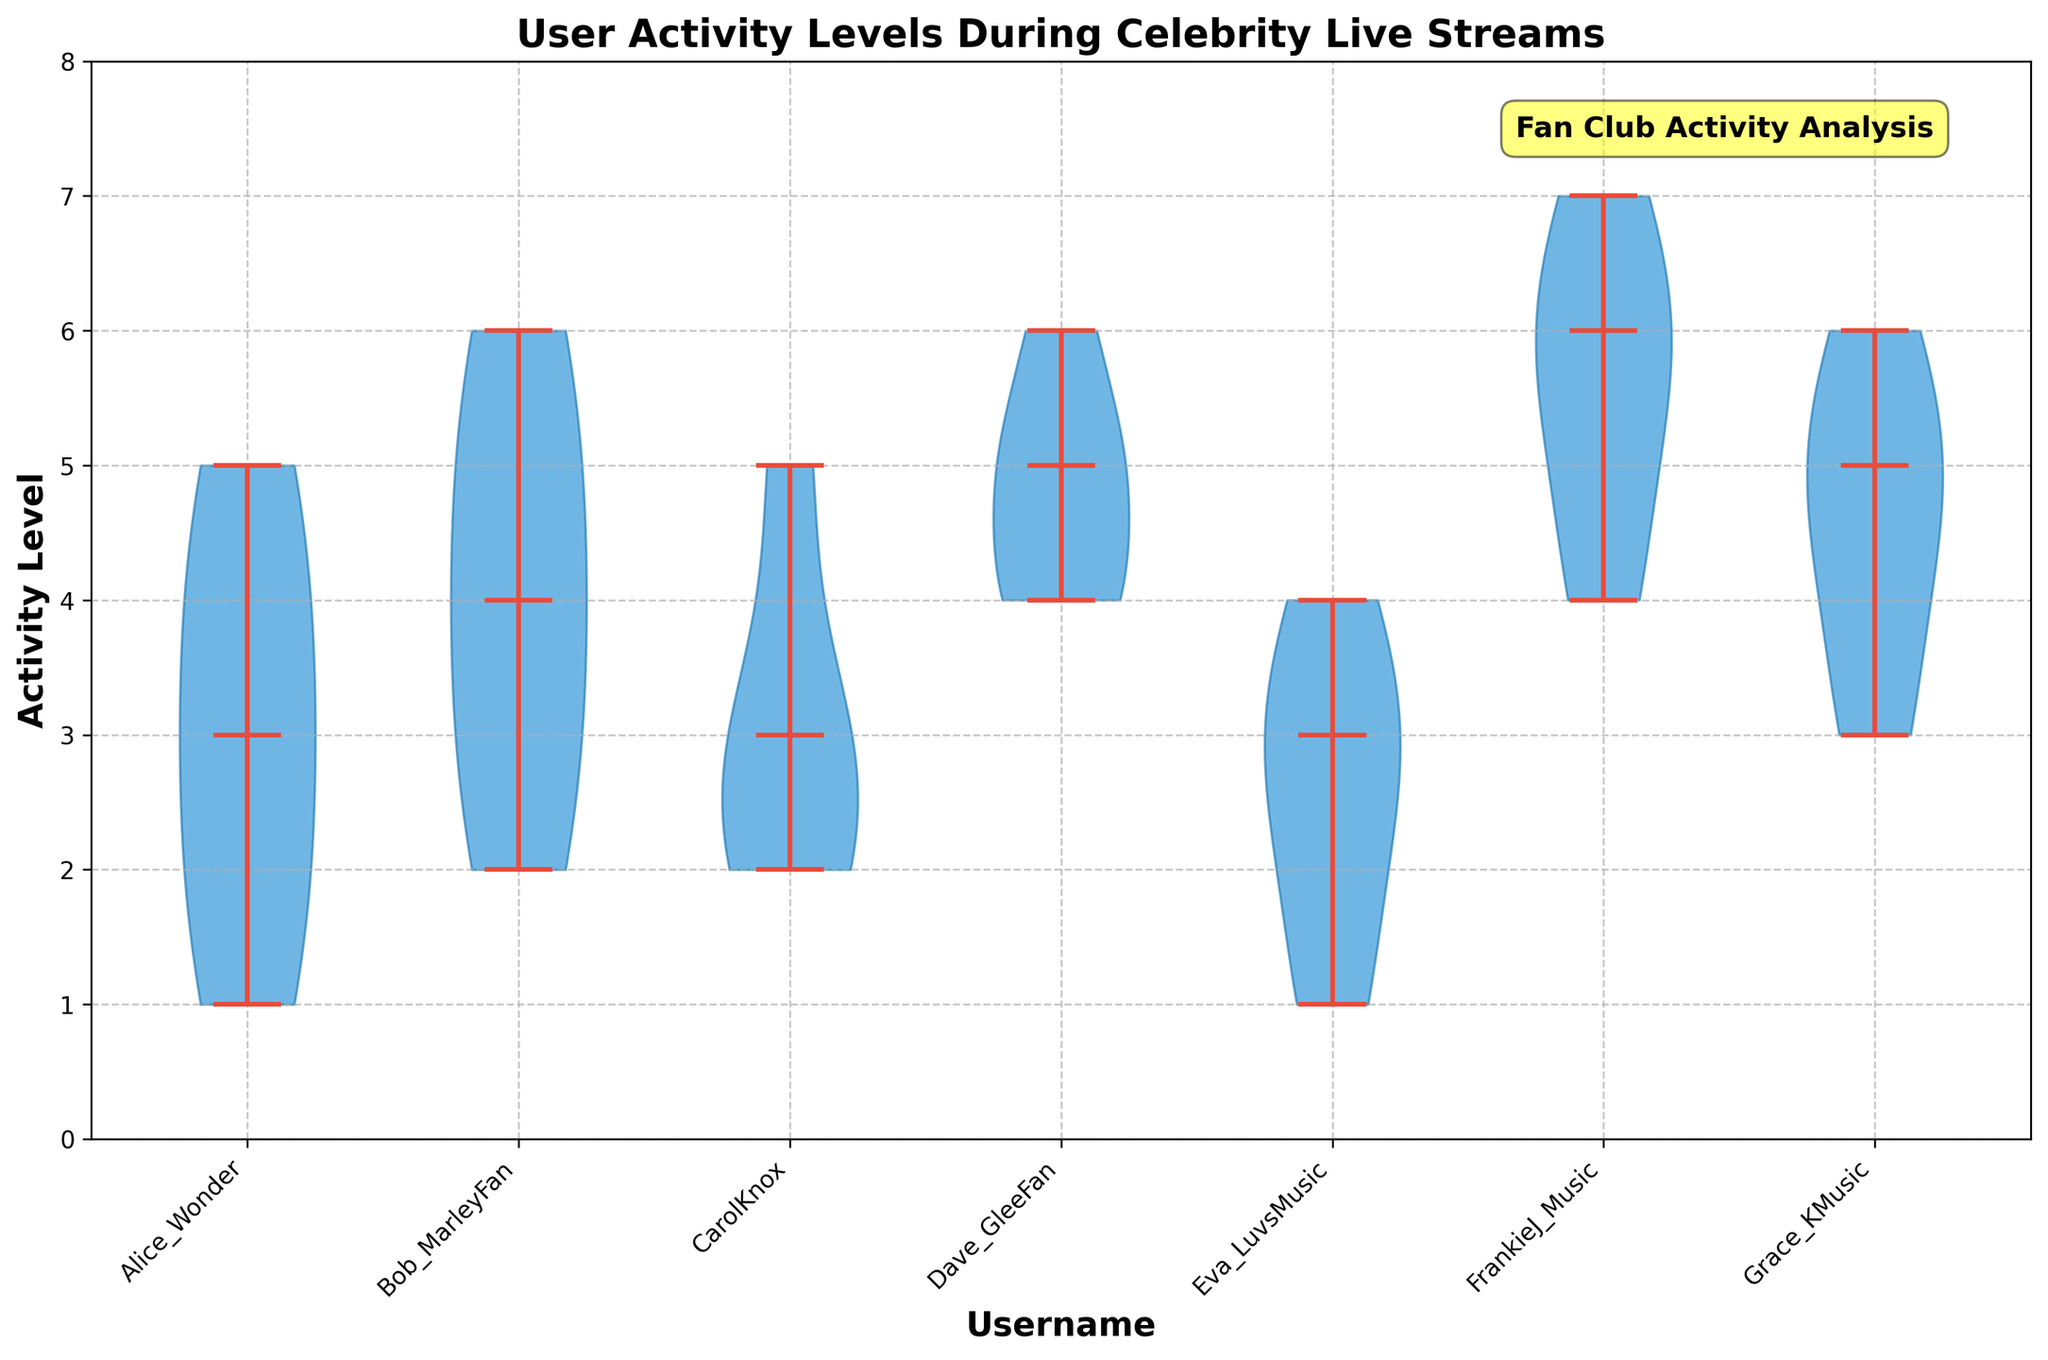Which username has the lowest activity level at any given minute? To find the lowest activity level, observe the minimum value for each user in the violin plot. The lowest activity level observed is 1. Several users like Alice_Wonder, Eva_LuvsMusic have this minimum activity level.
Answer: Alice_Wonder, Eva_LuvsMusic What is the title of the figure? The title is usually placed at the top of the figure, providing an overview of what the chart represents.
Answer: User Activity Levels During Celebrity Live Streams Which user's activity levels show the widest range? The widest range can be observed by examining the vertical spread of each violin plot. FrankieJ_Music's activity levels range from 4 to 7, which is a broad range compared to the others.
Answer: FrankieJ_Music What is the median activity level for Bob_MarleyFan? The median value is indicated by the white dot inside the violin plot. For Bob_MarleyFan, it is located at the middle of the range, which is 4.
Answer: 4 Which users have their activity levels most closely centered around the median? By looking at how tight the data is around the median line in the violin plots, Grace_KMusic and CarolKnox seem to have activity levels closely centered around their medians.
Answer: Grace_KMusic, CarolKnox Between Alice_Wonder and Dave_GleeFan, whose activity level is more variable? Variability is observed by the spread of the violin plot. Dave_GleeFan has a more extended and wider spread compared to Alice_Wonder, indicating higher variability.
Answer: Dave_GleeFan How many unique users' activity levels are depicted in this violin chart? By counting the number of separate violin plots, we find there are seven distinct usernames represented.
Answer: 7 Which user shows the highest peak activity level? The peak activity level is the highest point in any of the violin plots. FrankieJ_Music reaches an activity level of 7, which is the highest.
Answer: FrankieJ_Music If we average the median activity levels of all users, what is the result? The median activity levels are found in the middle of each violin plot. The median values are: Alice_Wonder (3), Bob_MarleyFan (4), CarolKnox (3), Dave_GleeFan (5), Eva_LuvsMusic (3), FrankieJ_Music (6), Grace_KMusic (5). Summing these and dividing by 7 gives (3+4+3+5+3+6+5)/7 = 4.14.
Answer: 4.14 